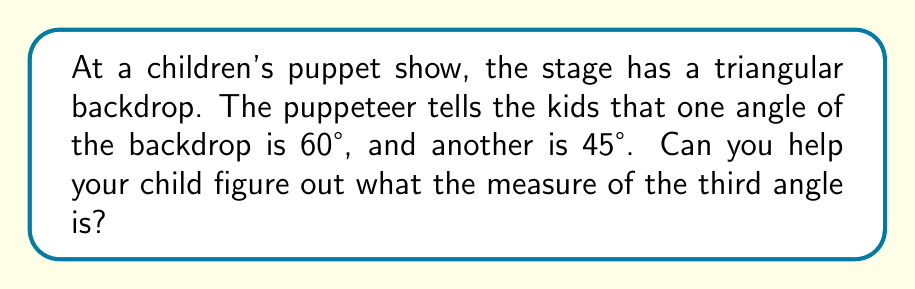Show me your answer to this math problem. Let's approach this step-by-step:

1) First, recall that the sum of angles in a triangle is always 180°. This is a fundamental property of triangles.

2) We can express this as an equation:
   $$ \text{Angle 1} + \text{Angle 2} + \text{Angle 3} = 180° $$

3) We know two of the angles:
   - Angle 1 = 60°
   - Angle 2 = 45°

4) Let's call the unknown angle x. We can now set up our equation:
   $$ 60° + 45° + x = 180° $$

5) Simplify the left side of the equation:
   $$ 105° + x = 180° $$

6) To solve for x, subtract 105° from both sides:
   $$ x = 180° - 105° $$

7) Calculate the result:
   $$ x = 75° $$

Therefore, the measure of the third angle in the triangular backdrop is 75°.
Answer: 75° 